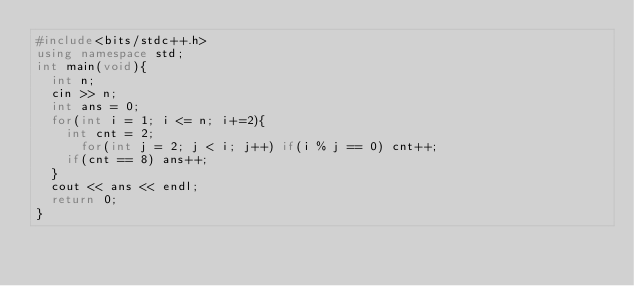Convert code to text. <code><loc_0><loc_0><loc_500><loc_500><_C++_>#include<bits/stdc++.h>
using namespace std;
int main(void){
	int n;
	cin >> n;
	int ans = 0;
	for(int i = 1; i <= n; i+=2){
		int cnt = 2;
			for(int j = 2; j < i; j++) if(i % j == 0) cnt++;
		if(cnt == 8) ans++;
	}
	cout << ans << endl;
	return 0;
}</code> 